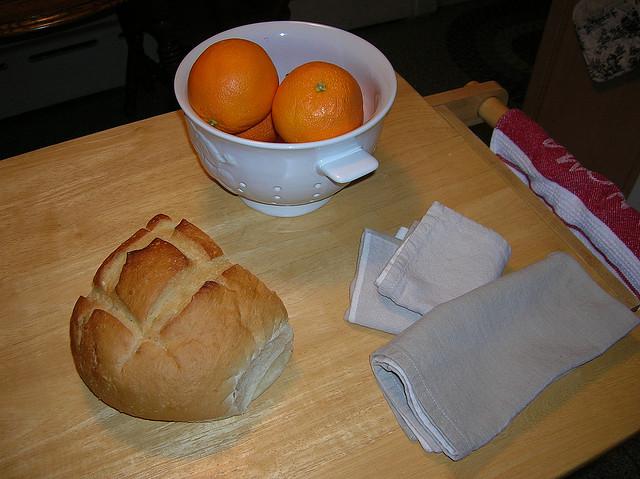Are those handkerchiefs on the table?
Write a very short answer. No. How many oranges are there?
Quick response, please. 3. Is there bread on the table?
Keep it brief. Yes. 